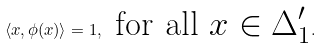<formula> <loc_0><loc_0><loc_500><loc_500>\langle x , \phi ( x ) \rangle = 1 , \text { for all $x\in \Delta^{\prime}_{1}$} .</formula> 